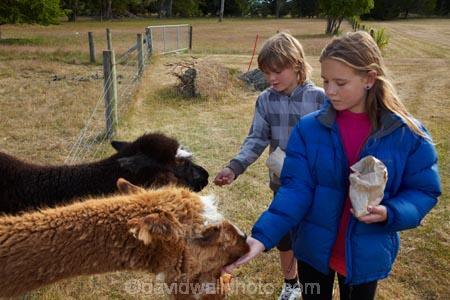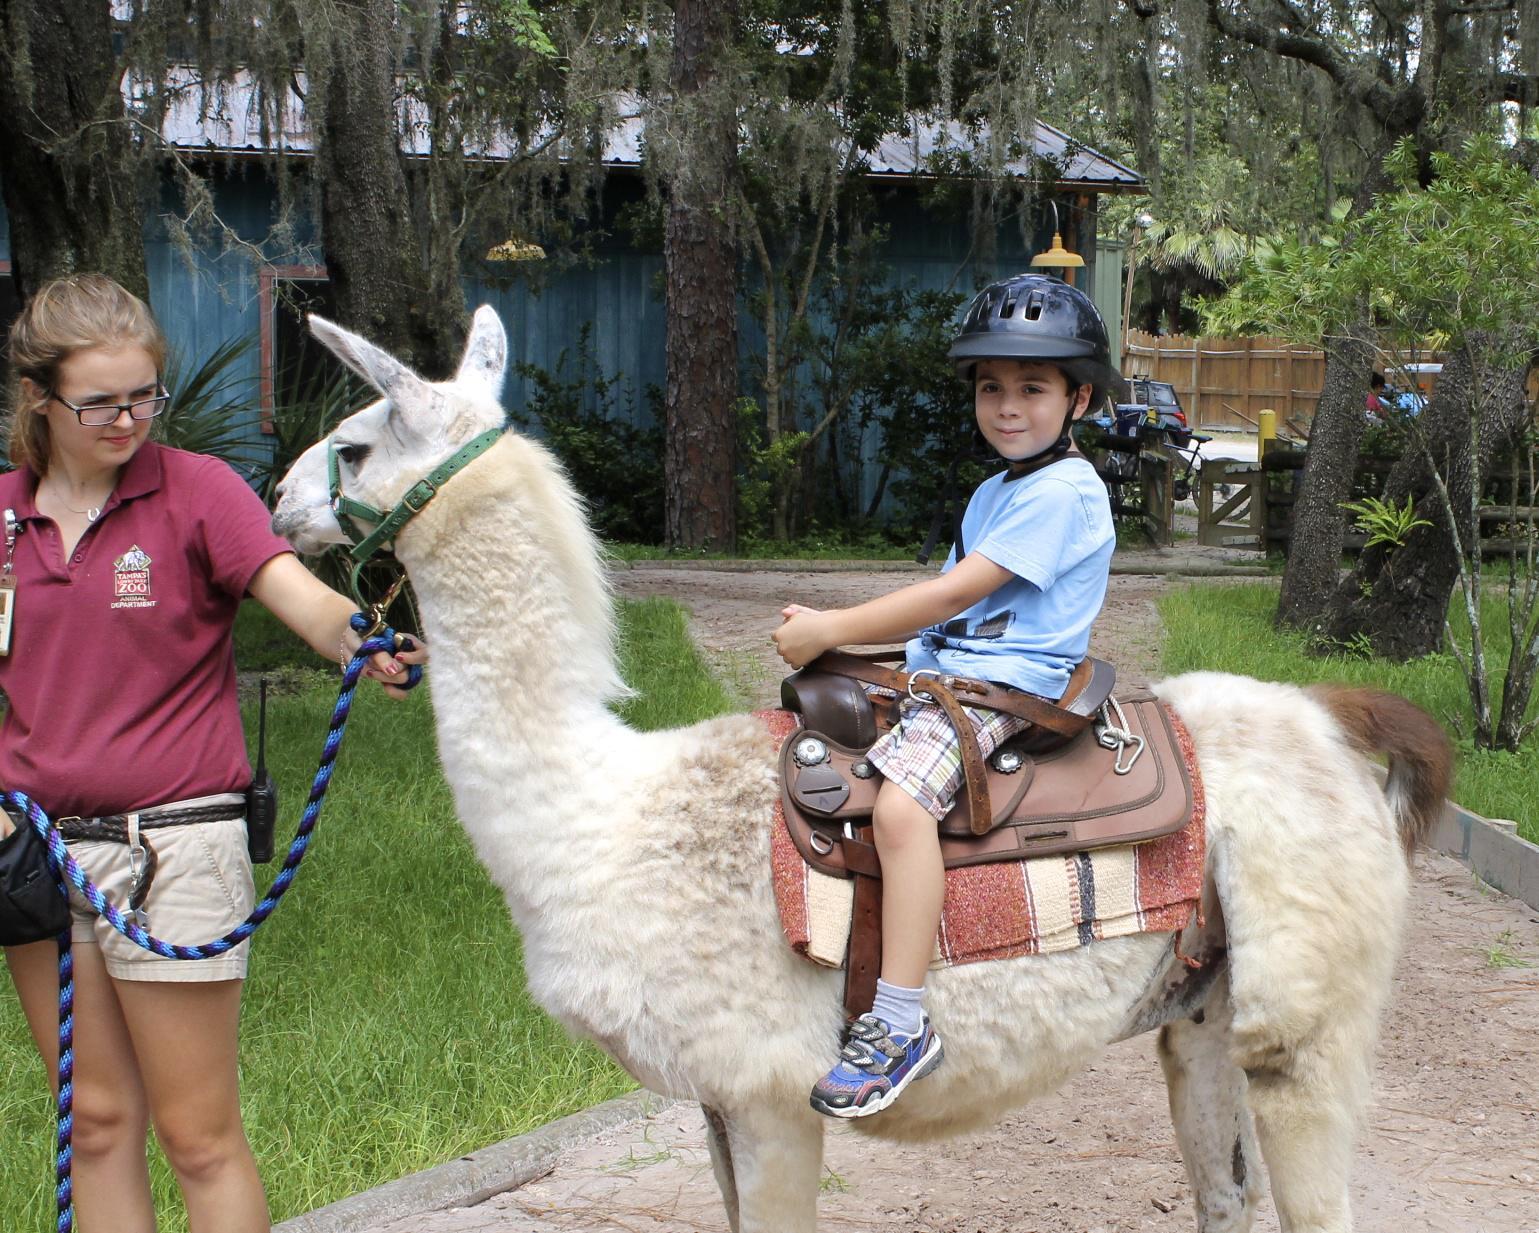The first image is the image on the left, the second image is the image on the right. Given the left and right images, does the statement "In one image, multiple children are standing in front of at least one llama, with their hands outstretched to feed it." hold true? Answer yes or no. Yes. The first image is the image on the left, the second image is the image on the right. Assess this claim about the two images: "There are children feeding a llama.". Correct or not? Answer yes or no. Yes. 